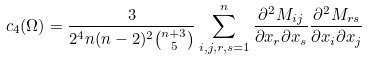<formula> <loc_0><loc_0><loc_500><loc_500>c _ { 4 } ( \Omega ) = \frac { 3 } { 2 ^ { 4 } n ( n - 2 ) ^ { 2 } { n + 3 \choose 5 } } \sum _ { i , j , r , s = 1 } ^ { n } \frac { \partial ^ { 2 } M _ { i j } } { \partial x _ { r } \partial x _ { s } } \frac { \partial ^ { 2 } M _ { r s } } { \partial x _ { i } \partial x _ { j } }</formula> 